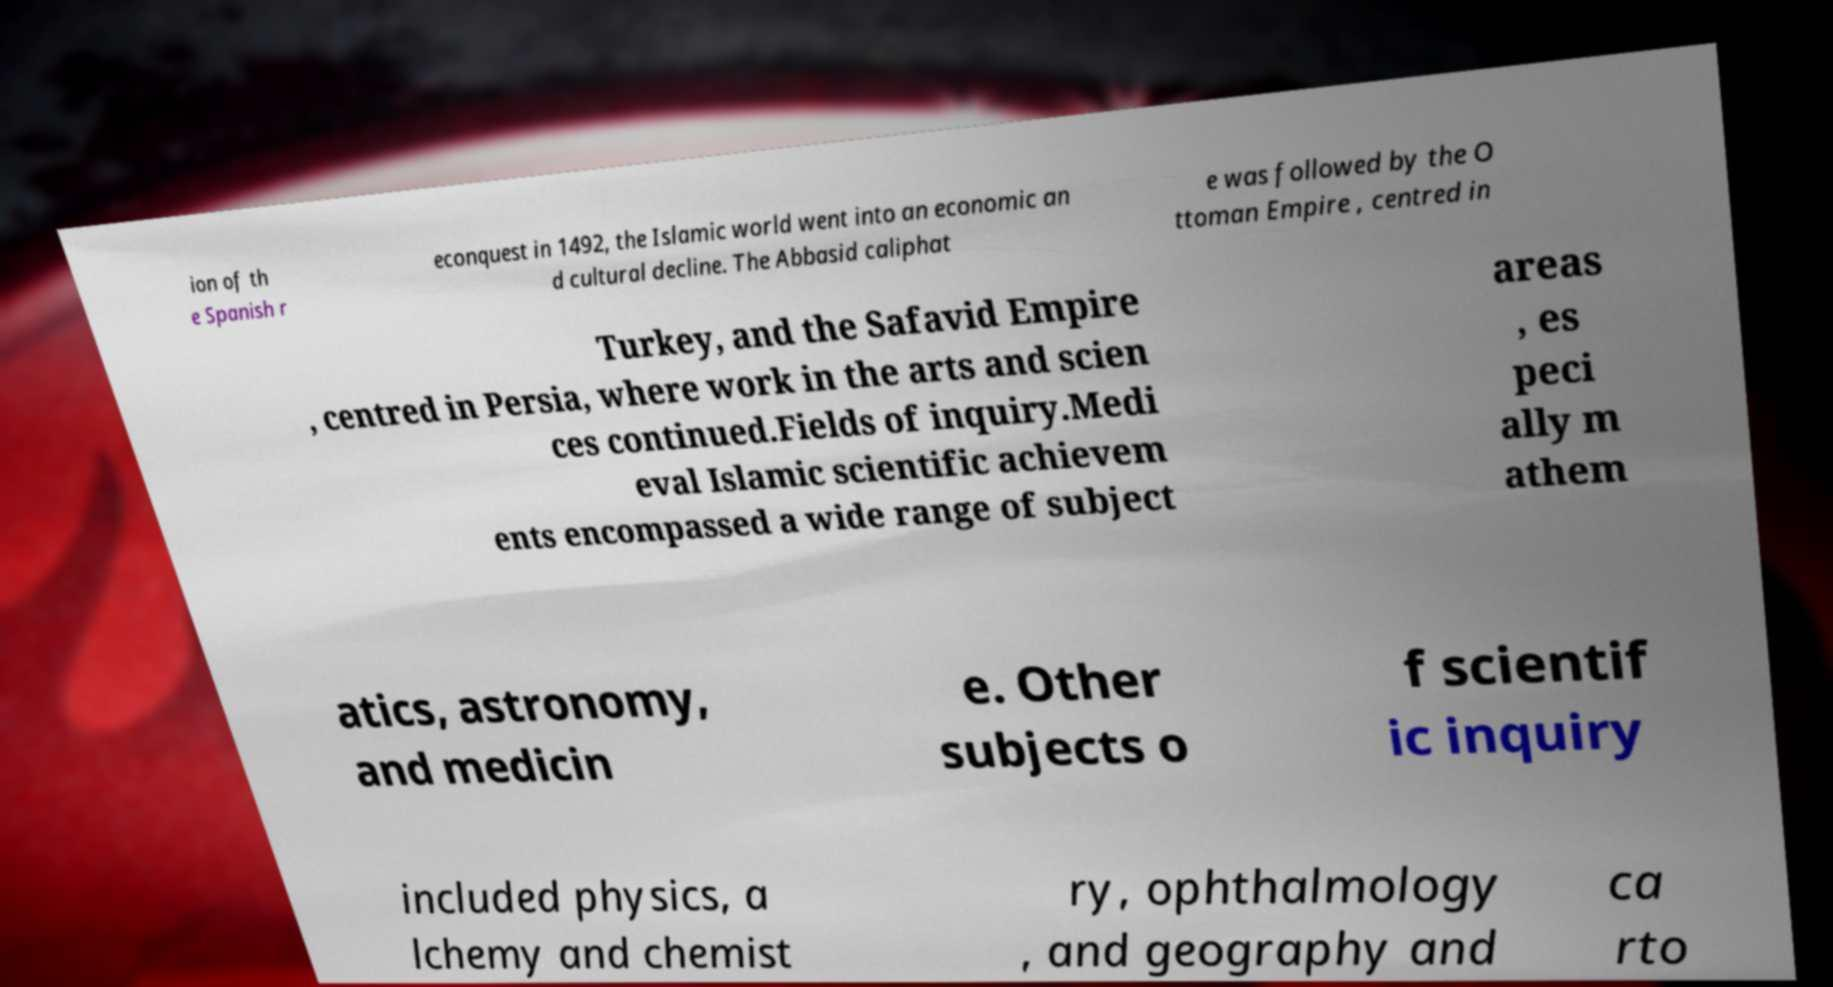Please identify and transcribe the text found in this image. ion of th e Spanish r econquest in 1492, the Islamic world went into an economic an d cultural decline. The Abbasid caliphat e was followed by the O ttoman Empire , centred in Turkey, and the Safavid Empire , centred in Persia, where work in the arts and scien ces continued.Fields of inquiry.Medi eval Islamic scientific achievem ents encompassed a wide range of subject areas , es peci ally m athem atics, astronomy, and medicin e. Other subjects o f scientif ic inquiry included physics, a lchemy and chemist ry, ophthalmology , and geography and ca rto 